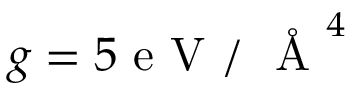<formula> <loc_0><loc_0><loc_500><loc_500>g = 5 e V / \AA ^ { 4 }</formula> 